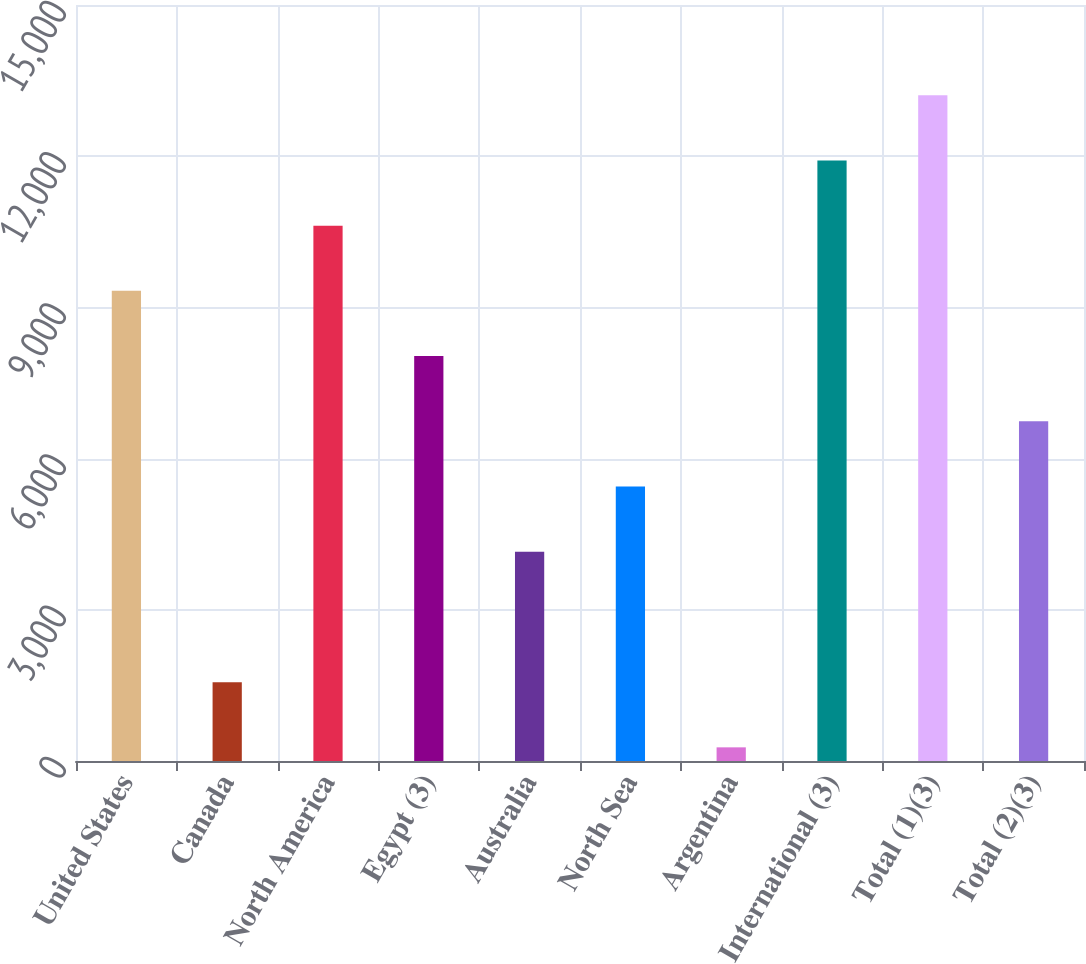Convert chart to OTSL. <chart><loc_0><loc_0><loc_500><loc_500><bar_chart><fcel>United States<fcel>Canada<fcel>North America<fcel>Egypt (3)<fcel>Australia<fcel>North Sea<fcel>Argentina<fcel>International (3)<fcel>Total (1)(3)<fcel>Total (2)(3)<nl><fcel>9328.3<fcel>1564.9<fcel>10622.2<fcel>8034.4<fcel>4152.7<fcel>5446.6<fcel>271<fcel>11916.1<fcel>13210<fcel>6740.5<nl></chart> 